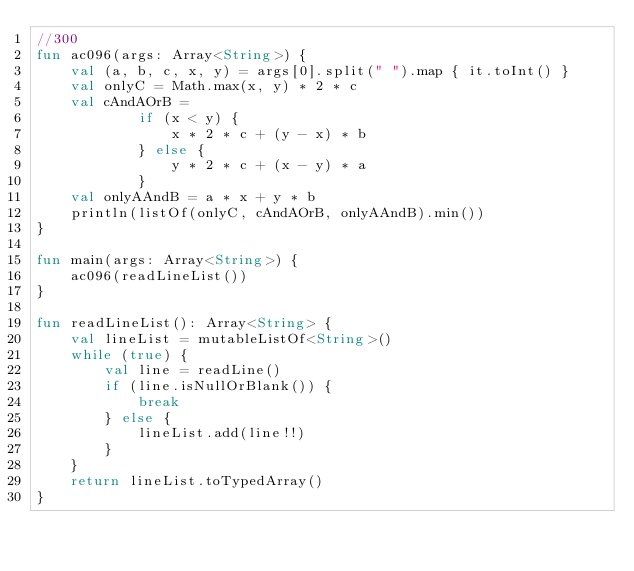Convert code to text. <code><loc_0><loc_0><loc_500><loc_500><_Kotlin_>//300
fun ac096(args: Array<String>) {
    val (a, b, c, x, y) = args[0].split(" ").map { it.toInt() }
    val onlyC = Math.max(x, y) * 2 * c
    val cAndAOrB =
            if (x < y) {
                x * 2 * c + (y - x) * b
            } else {
                y * 2 * c + (x - y) * a
            }
    val onlyAAndB = a * x + y * b
    println(listOf(onlyC, cAndAOrB, onlyAAndB).min())
}

fun main(args: Array<String>) {
    ac096(readLineList())
}

fun readLineList(): Array<String> {
    val lineList = mutableListOf<String>()
    while (true) {
        val line = readLine()
        if (line.isNullOrBlank()) {
            break
        } else {
            lineList.add(line!!)
        }
    }
    return lineList.toTypedArray()
}</code> 